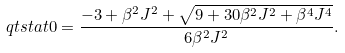<formula> <loc_0><loc_0><loc_500><loc_500>\ q t s t a t { 0 } = \frac { - 3 + \beta ^ { 2 } J ^ { 2 } + \sqrt { 9 + 3 0 \beta ^ { 2 } J ^ { 2 } + \beta ^ { 4 } J ^ { 4 } } } { 6 \beta ^ { 2 } J ^ { 2 } } .</formula> 